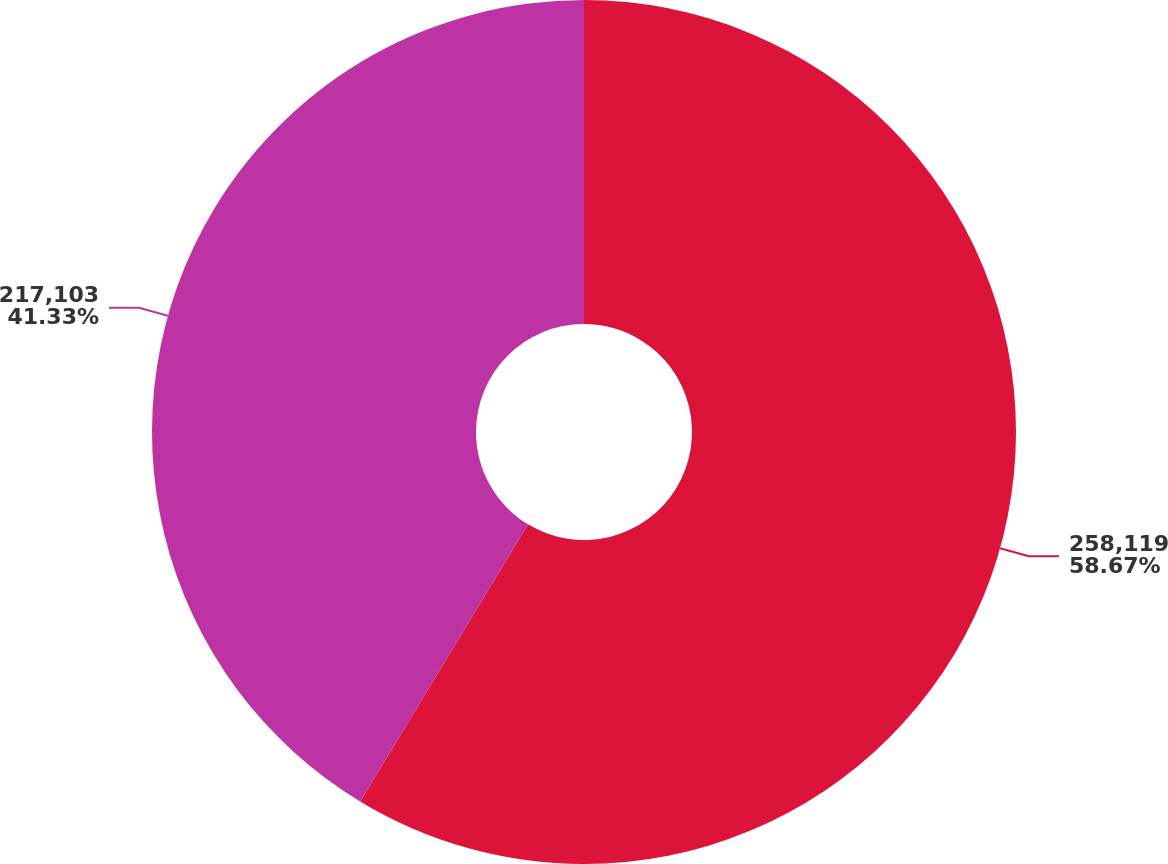<chart> <loc_0><loc_0><loc_500><loc_500><pie_chart><fcel>258,119<fcel>217,103<nl><fcel>58.67%<fcel>41.33%<nl></chart> 